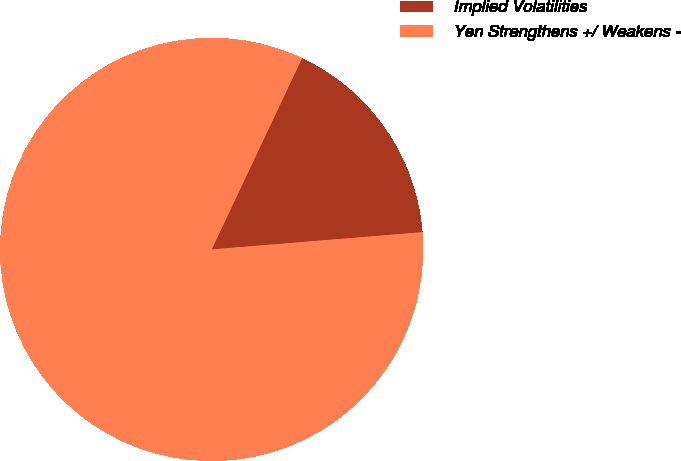Convert chart to OTSL. <chart><loc_0><loc_0><loc_500><loc_500><pie_chart><fcel>Implied Volatilities<fcel>Yen Strengthens +/ Weakens -<nl><fcel>16.67%<fcel>83.33%<nl></chart> 